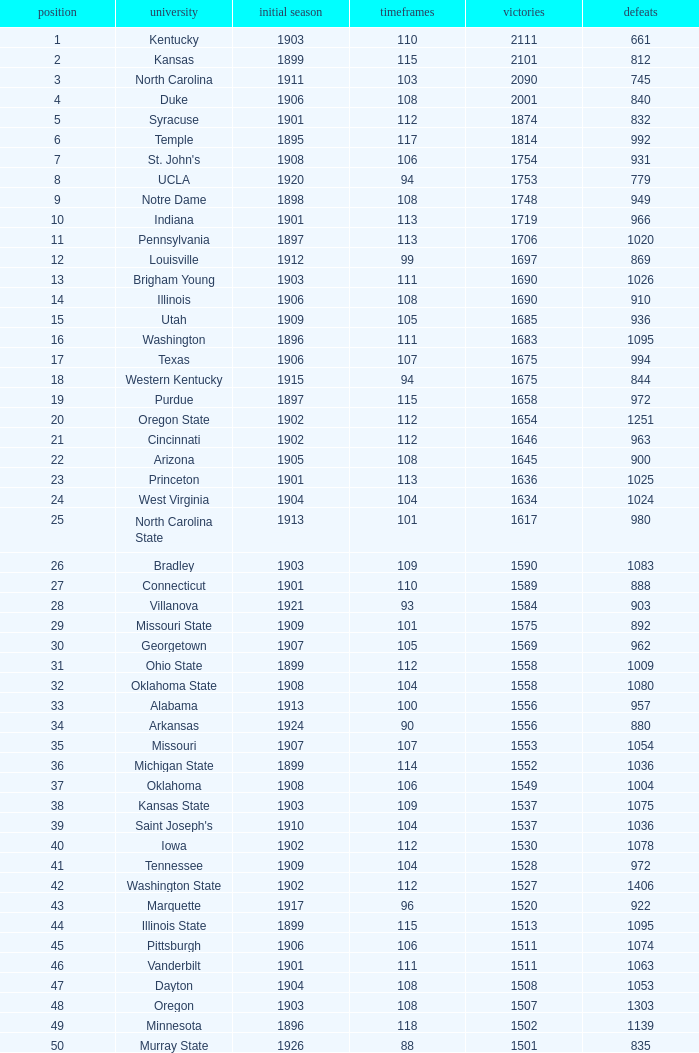What is the total number of rank with losses less than 992, North Carolina State College and a season greater than 101? 0.0. 